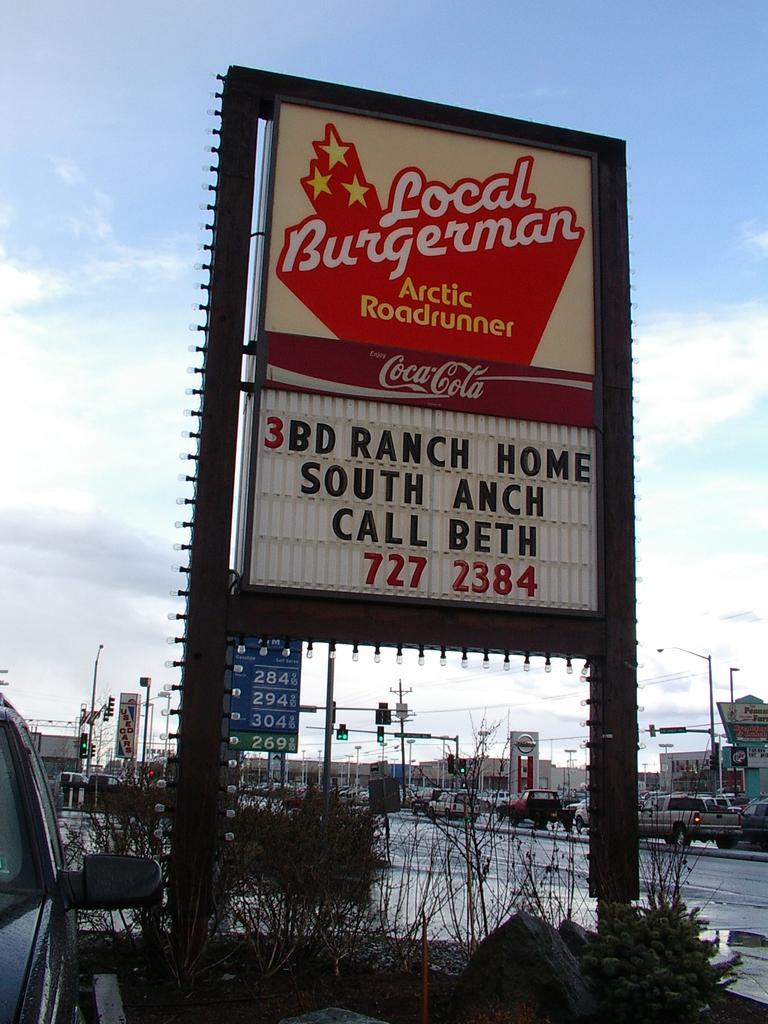Could you give a brief overview of what you see in this image? In the middle it is a boat, on the right side there is a road. At the top it's a sky. 